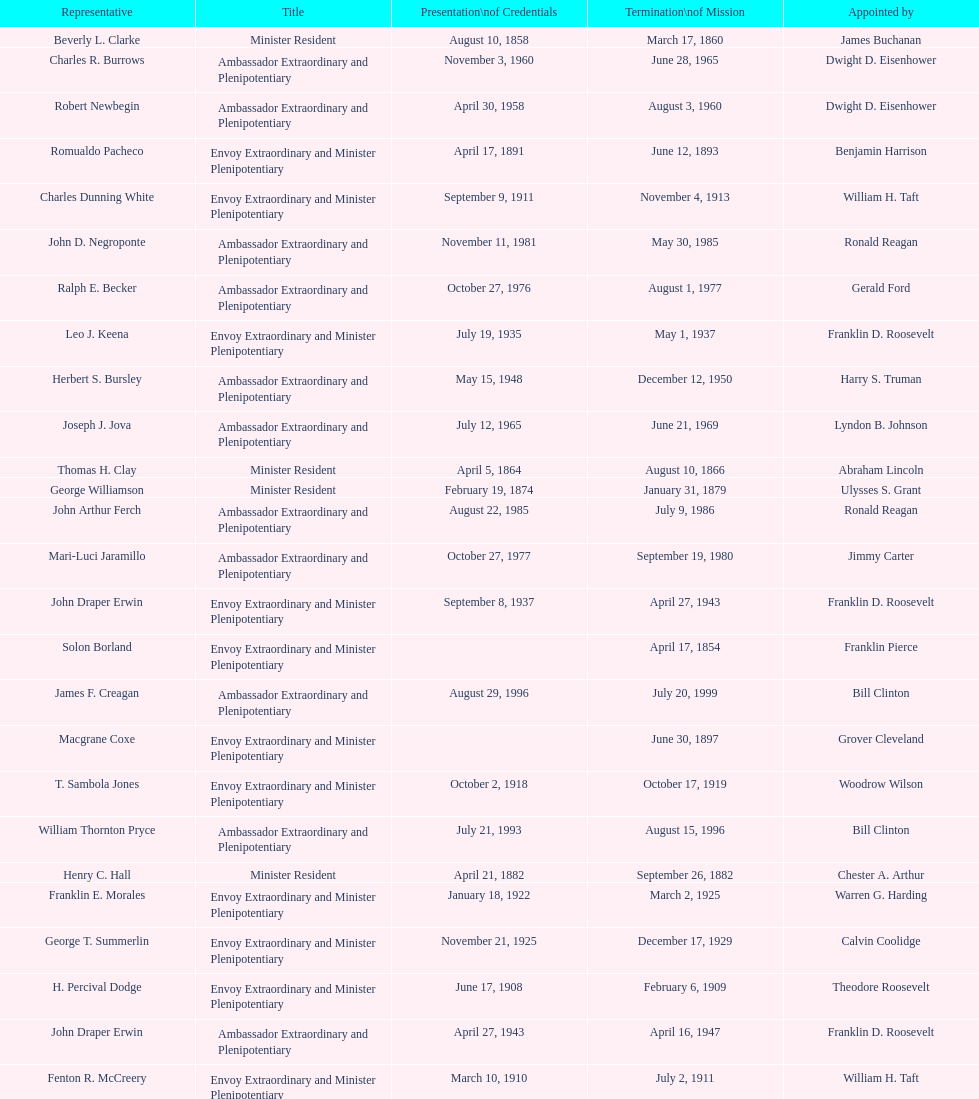Who is the only ambassadors to honduras appointed by barack obama? Lisa Kubiske. 